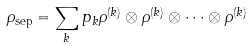<formula> <loc_0><loc_0><loc_500><loc_500>\rho _ { \text {sep} } = \sum _ { k } p _ { k } \rho ^ { ( k ) } \otimes \rho ^ { ( k ) } \otimes \cdots \otimes \rho ^ { ( k ) }</formula> 